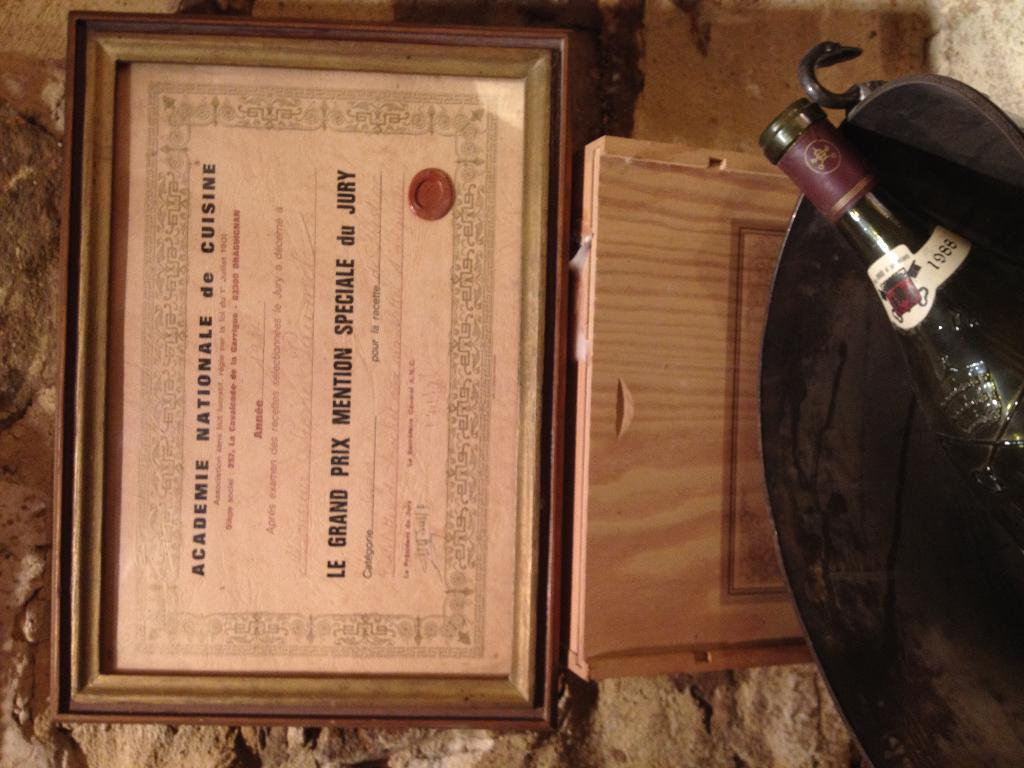What is the main object in the image? There is a frame in the image. What is inside the frame? There is a certificate inside the frame. What is the bottle placed in? The bottle is placed in a bucket. What type of structure is visible in the image? There is a rock wall visible in the image. What type of verse can be seen written on the stocking in the image? There is no stocking or verse present in the image. What type of lamp is visible on the rock wall in the image? There is no lamp visible on the rock wall in the image. 